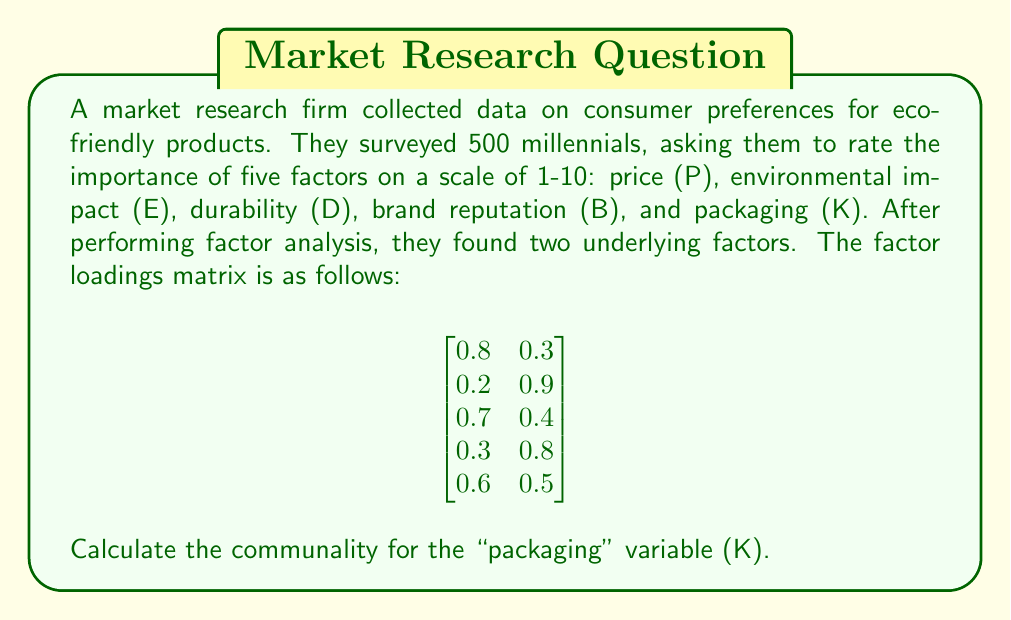Show me your answer to this math problem. To solve this problem, we need to understand the concept of communality in factor analysis and how to calculate it using the factor loadings matrix.

1. Communality represents the proportion of a variable's variance that can be explained by the common factors.

2. It is calculated as the sum of squared factor loadings for each variable across all factors.

3. In this case, we have two factors, so we'll use the following formula:
   $$ h_i^2 = \sum_{j=1}^k a_{ij}^2 $$
   where $h_i^2$ is the communality for variable $i$, $k$ is the number of factors, and $a_{ij}$ is the factor loading for variable $i$ on factor $j$.

4. The packaging variable (K) is represented by the last row of the factor loadings matrix:
   $$ [0.6 \quad 0.5] $$

5. To calculate the communality, we square each factor loading and sum them:
   $$ h_K^2 = (0.6)^2 + (0.5)^2 $$

6. Calculating:
   $$ h_K^2 = 0.36 + 0.25 = 0.61 $$

Therefore, the communality for the packaging variable (K) is 0.61.
Answer: 0.61 